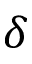Convert formula to latex. <formula><loc_0><loc_0><loc_500><loc_500>\delta</formula> 